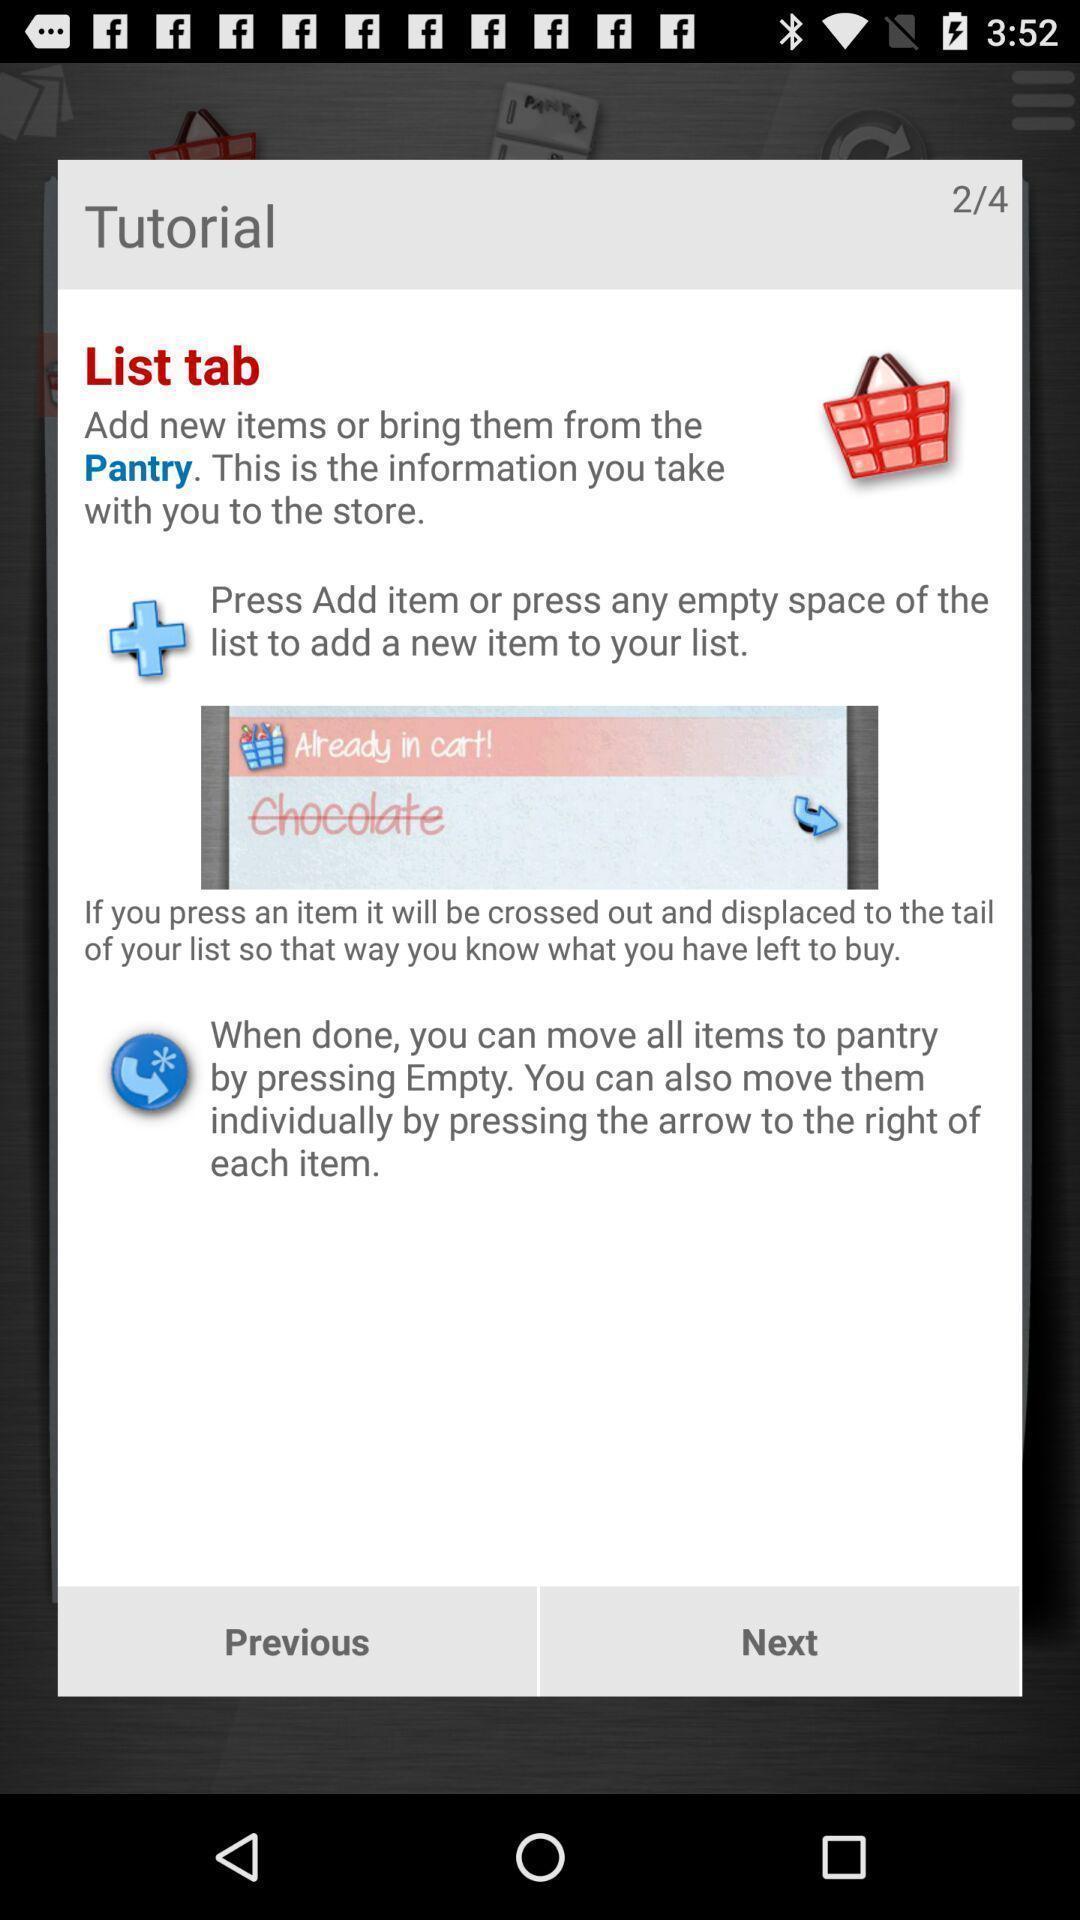Please provide a description for this image. Pop-up displaying instructions to add items in the pantry list. 